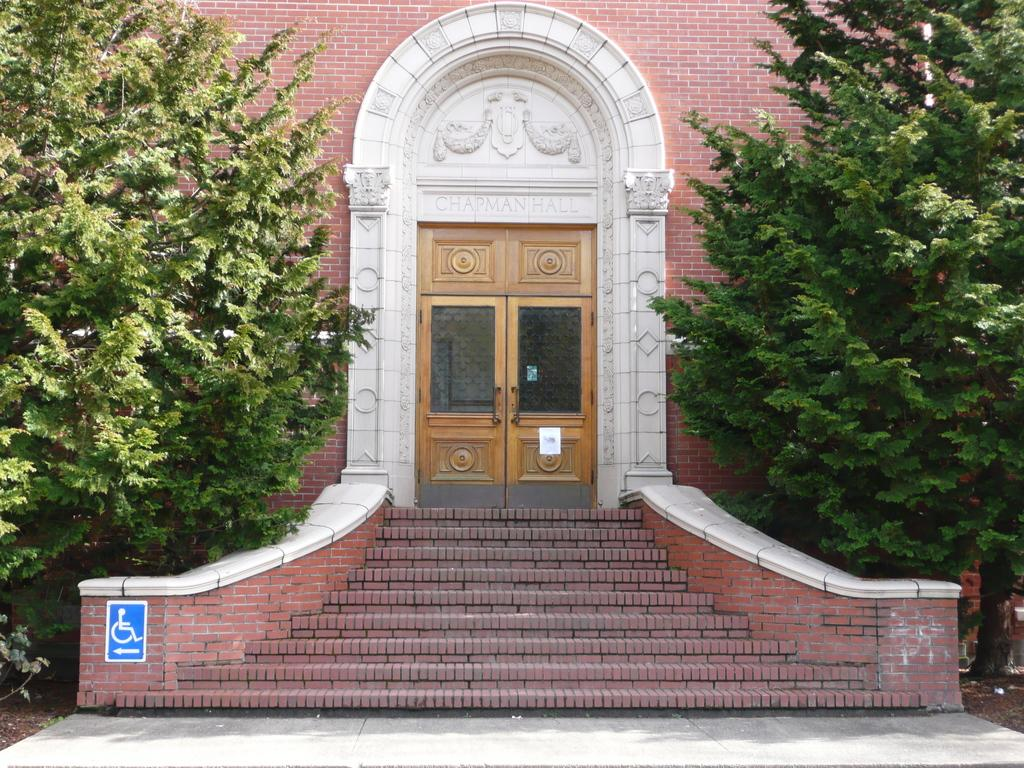What type of structure is visible in the image? There is a building in the image. What material are the doors of the building made of? The building has wooden doors. Are there any architectural features in the image? Yes, there are steps in the image. What is attached to the wall of the building? There is a sign board attached to the wall. What type of vegetation is present in the image? There are two trees in the image. Can you hear the basketball bouncing in the image? There is no basketball present in the image, so it is not possible to hear it bouncing. 